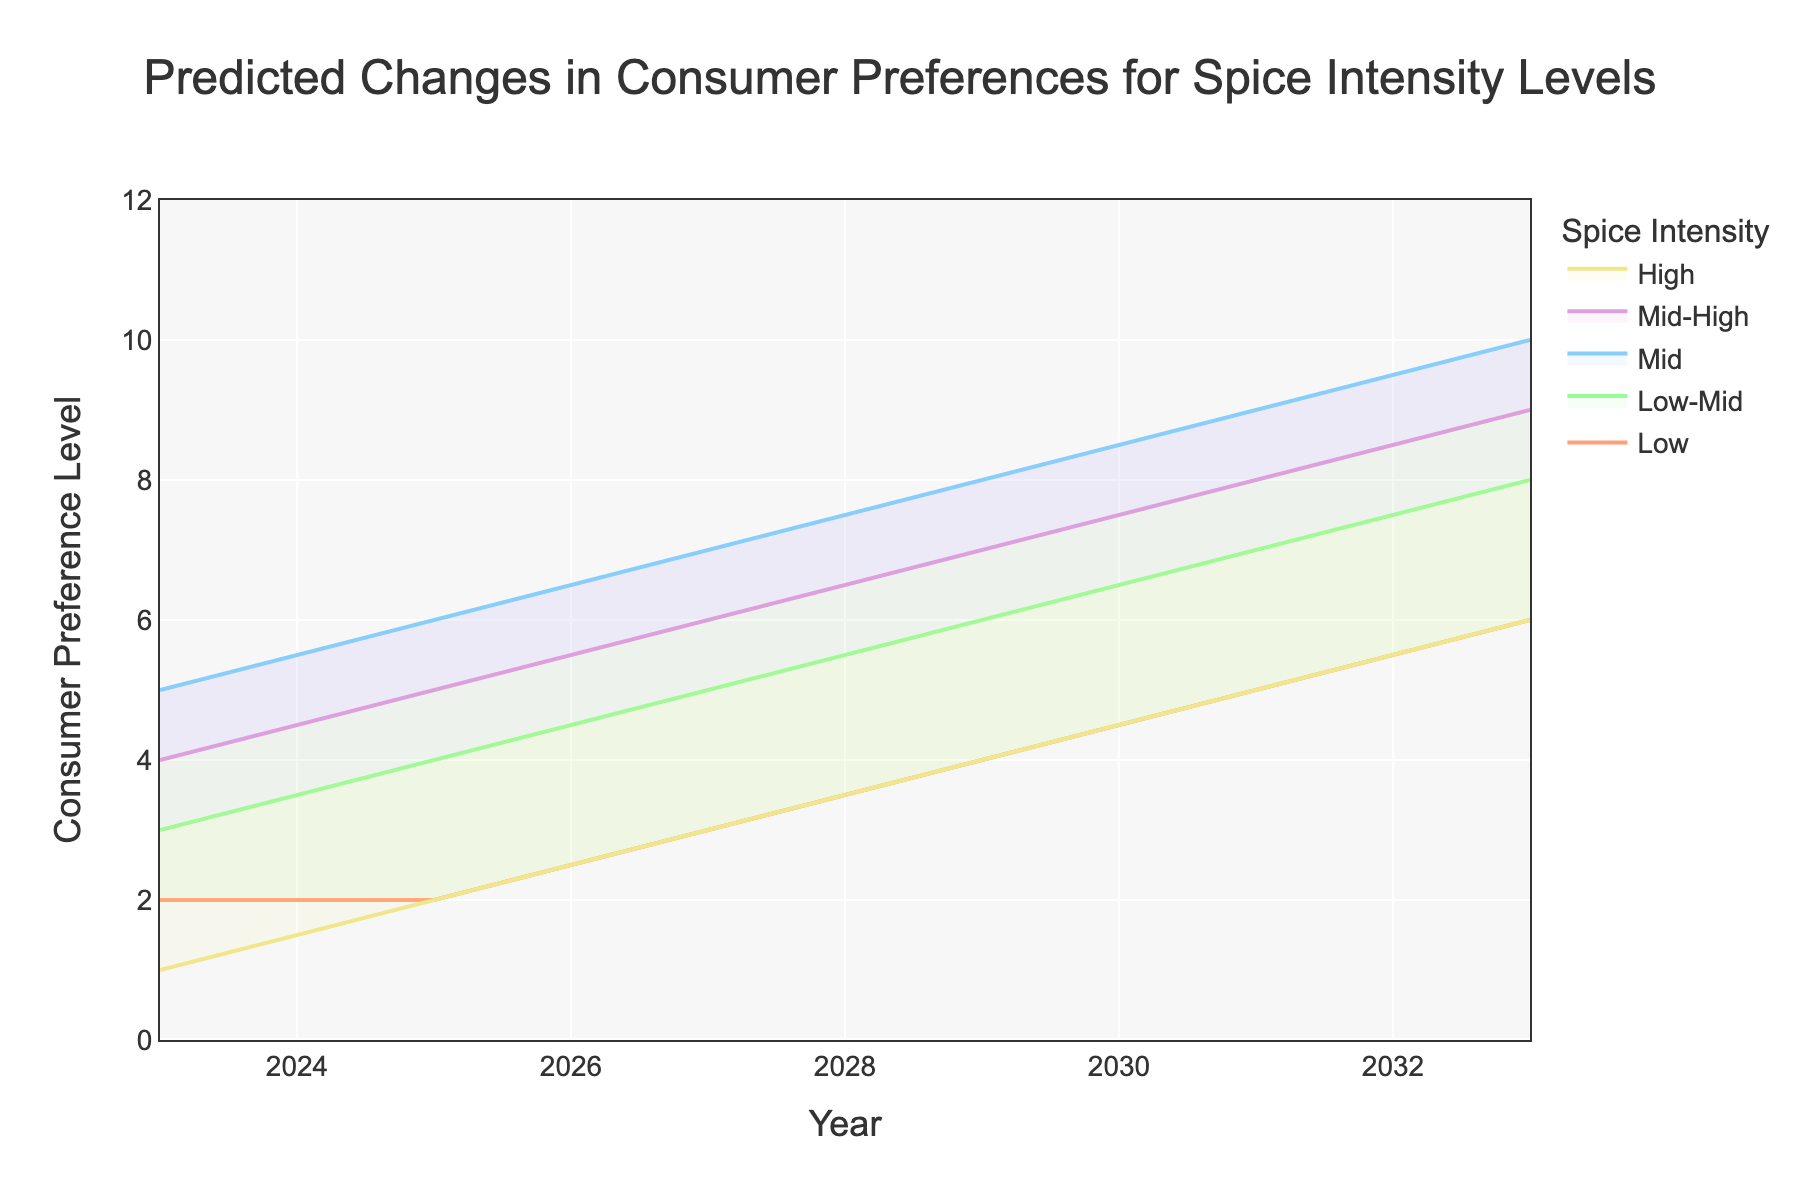What is the title of the chart? The title of the chart is displayed prominently at the top and reads "Predicted Changes in Consumer Preferences for Spice Intensity Levels".
Answer: Predicted Changes in Consumer Preferences for Spice Intensity Levels What is the predicted consumer preference level for "Mid" spice intensity in 2029? Find the "Mid" data line and locate the point corresponding to the year 2029. The value at this point on the chart is 8.
Answer: 8 Which spice intensity level has the highest predicted consumer preference in 2033? Look at the endpoints for each intensity level in the year 2033 and find the highest value, which corresponds to "Mid" with a value of 10.
Answer: Mid How does the consumer preference for "Low" spice intensity change from 2023 to 2033? Compare the "Low" values at 2023 and 2033. In 2023, the value is 2 and in 2033, it is 6, indicating an increase.
Answer: It increases What is the average predicted consumer preference level for "High" spice intensity in the years provided? Sum the values for "High" spice intensity across all provided years (1 + 2 + 3 + 4 + 5 + 6) and divide by the number of years (6). (1+2+3+4+5+6)/6 = 3.5
Answer: 3.5 Which two spice intensity levels have the closest predicted values in 2025? Look at the values for each spice intensity in 2025: Low (2), Low-Mid (4), Mid (6), Mid-High (5), High (2). The closest values are for "Low" and "High" with both having a value of 2.
Answer: Low and High Is there any year where all the spice intensity levels have different predicted values? Examine the predicted values for each spice intensity level across all years. 2023 has all different values (2, 3, 5, 4, 1).
Answer: Yes, 2023 Which spice intensity level shows a consistent increase in consumer preference from 2023 to 2033? Analyze each intensity level's values across the years. All levels show a consistent increase: "Low" (2 to 6), "Low-Mid" (3 to 8), "Mid" (5 to 10), "Mid-High" (4 to 9), "High" (1 to 6).
Answer: All levels In which year does the "Mid-High" spice intensity level first surpass a consumer preference value of 6? Check the values for "Mid-High" across the years. It surpasses 6 in 2027 (value becomes 6).
Answer: 2027 